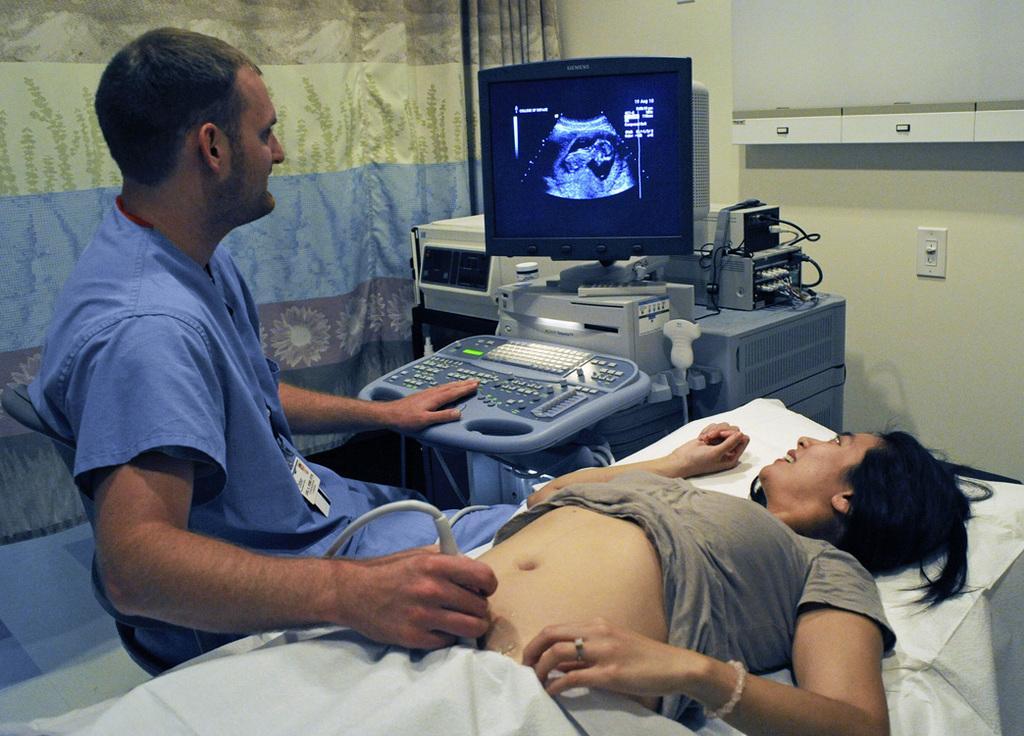Describe this image in one or two sentences. In this image we can see a woman sleeping on the bed and she having a look at the monitor. Here we can see a man sitting on the chair and he is holding the medical equipment in his right hand. Here we can see the medical equipment. Here we can see the curtains. 